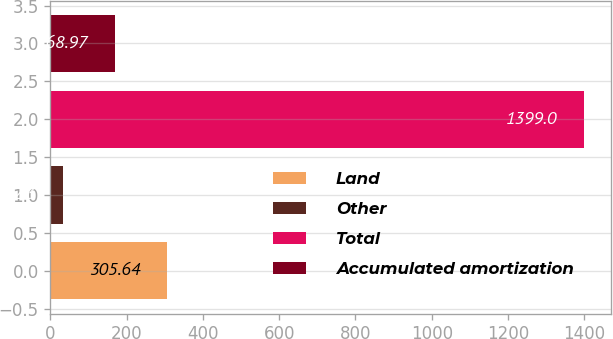Convert chart to OTSL. <chart><loc_0><loc_0><loc_500><loc_500><bar_chart><fcel>Land<fcel>Other<fcel>Total<fcel>Accumulated amortization<nl><fcel>305.64<fcel>32.3<fcel>1399<fcel>168.97<nl></chart> 